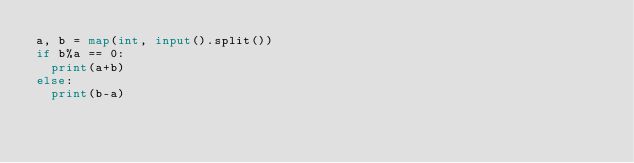<code> <loc_0><loc_0><loc_500><loc_500><_Python_>a, b = map(int, input().split())
if b%a == 0:
  print(a+b)
else:
  print(b-a)</code> 